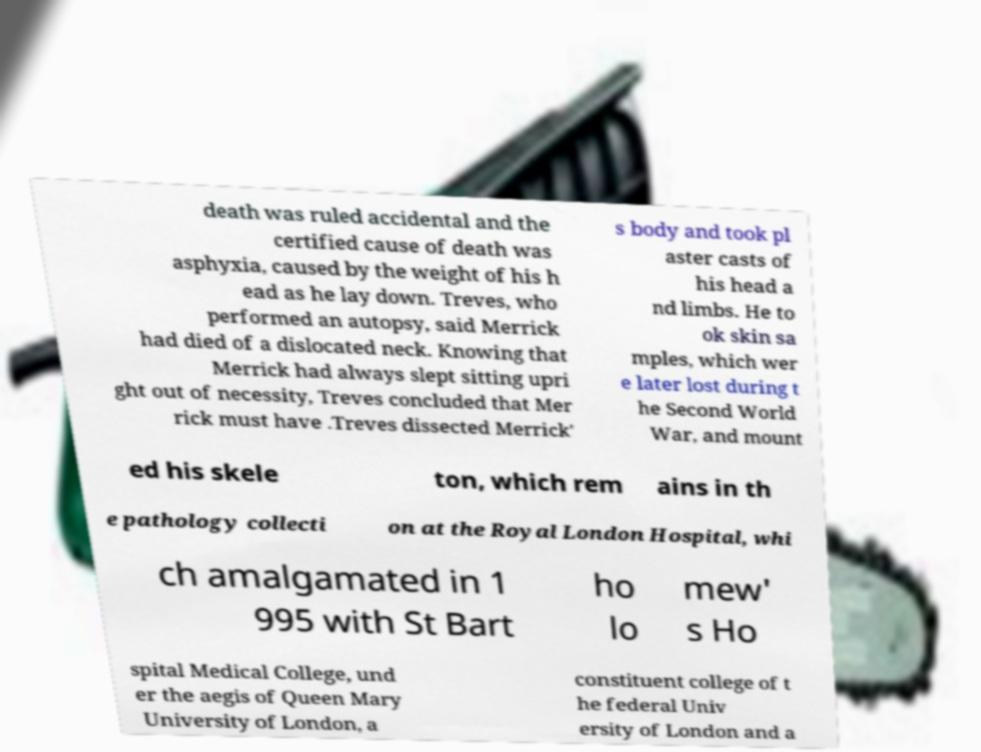Could you assist in decoding the text presented in this image and type it out clearly? death was ruled accidental and the certified cause of death was asphyxia, caused by the weight of his h ead as he lay down. Treves, who performed an autopsy, said Merrick had died of a dislocated neck. Knowing that Merrick had always slept sitting upri ght out of necessity, Treves concluded that Mer rick must have .Treves dissected Merrick' s body and took pl aster casts of his head a nd limbs. He to ok skin sa mples, which wer e later lost during t he Second World War, and mount ed his skele ton, which rem ains in th e pathology collecti on at the Royal London Hospital, whi ch amalgamated in 1 995 with St Bart ho lo mew' s Ho spital Medical College, und er the aegis of Queen Mary University of London, a constituent college of t he federal Univ ersity of London and a 